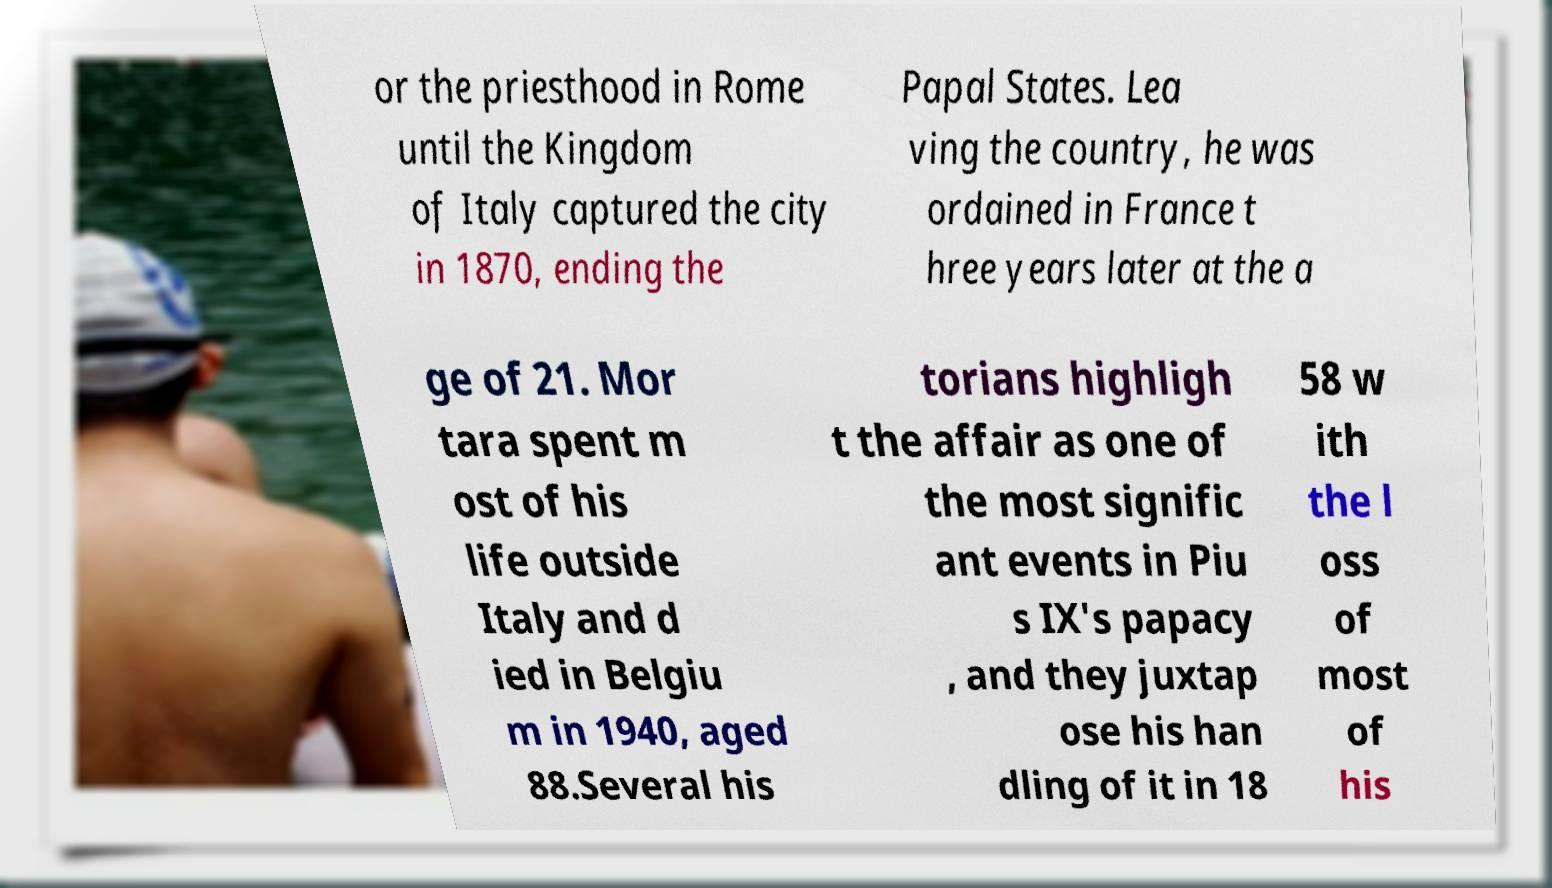I need the written content from this picture converted into text. Can you do that? or the priesthood in Rome until the Kingdom of Italy captured the city in 1870, ending the Papal States. Lea ving the country, he was ordained in France t hree years later at the a ge of 21. Mor tara spent m ost of his life outside Italy and d ied in Belgiu m in 1940, aged 88.Several his torians highligh t the affair as one of the most signific ant events in Piu s IX's papacy , and they juxtap ose his han dling of it in 18 58 w ith the l oss of most of his 